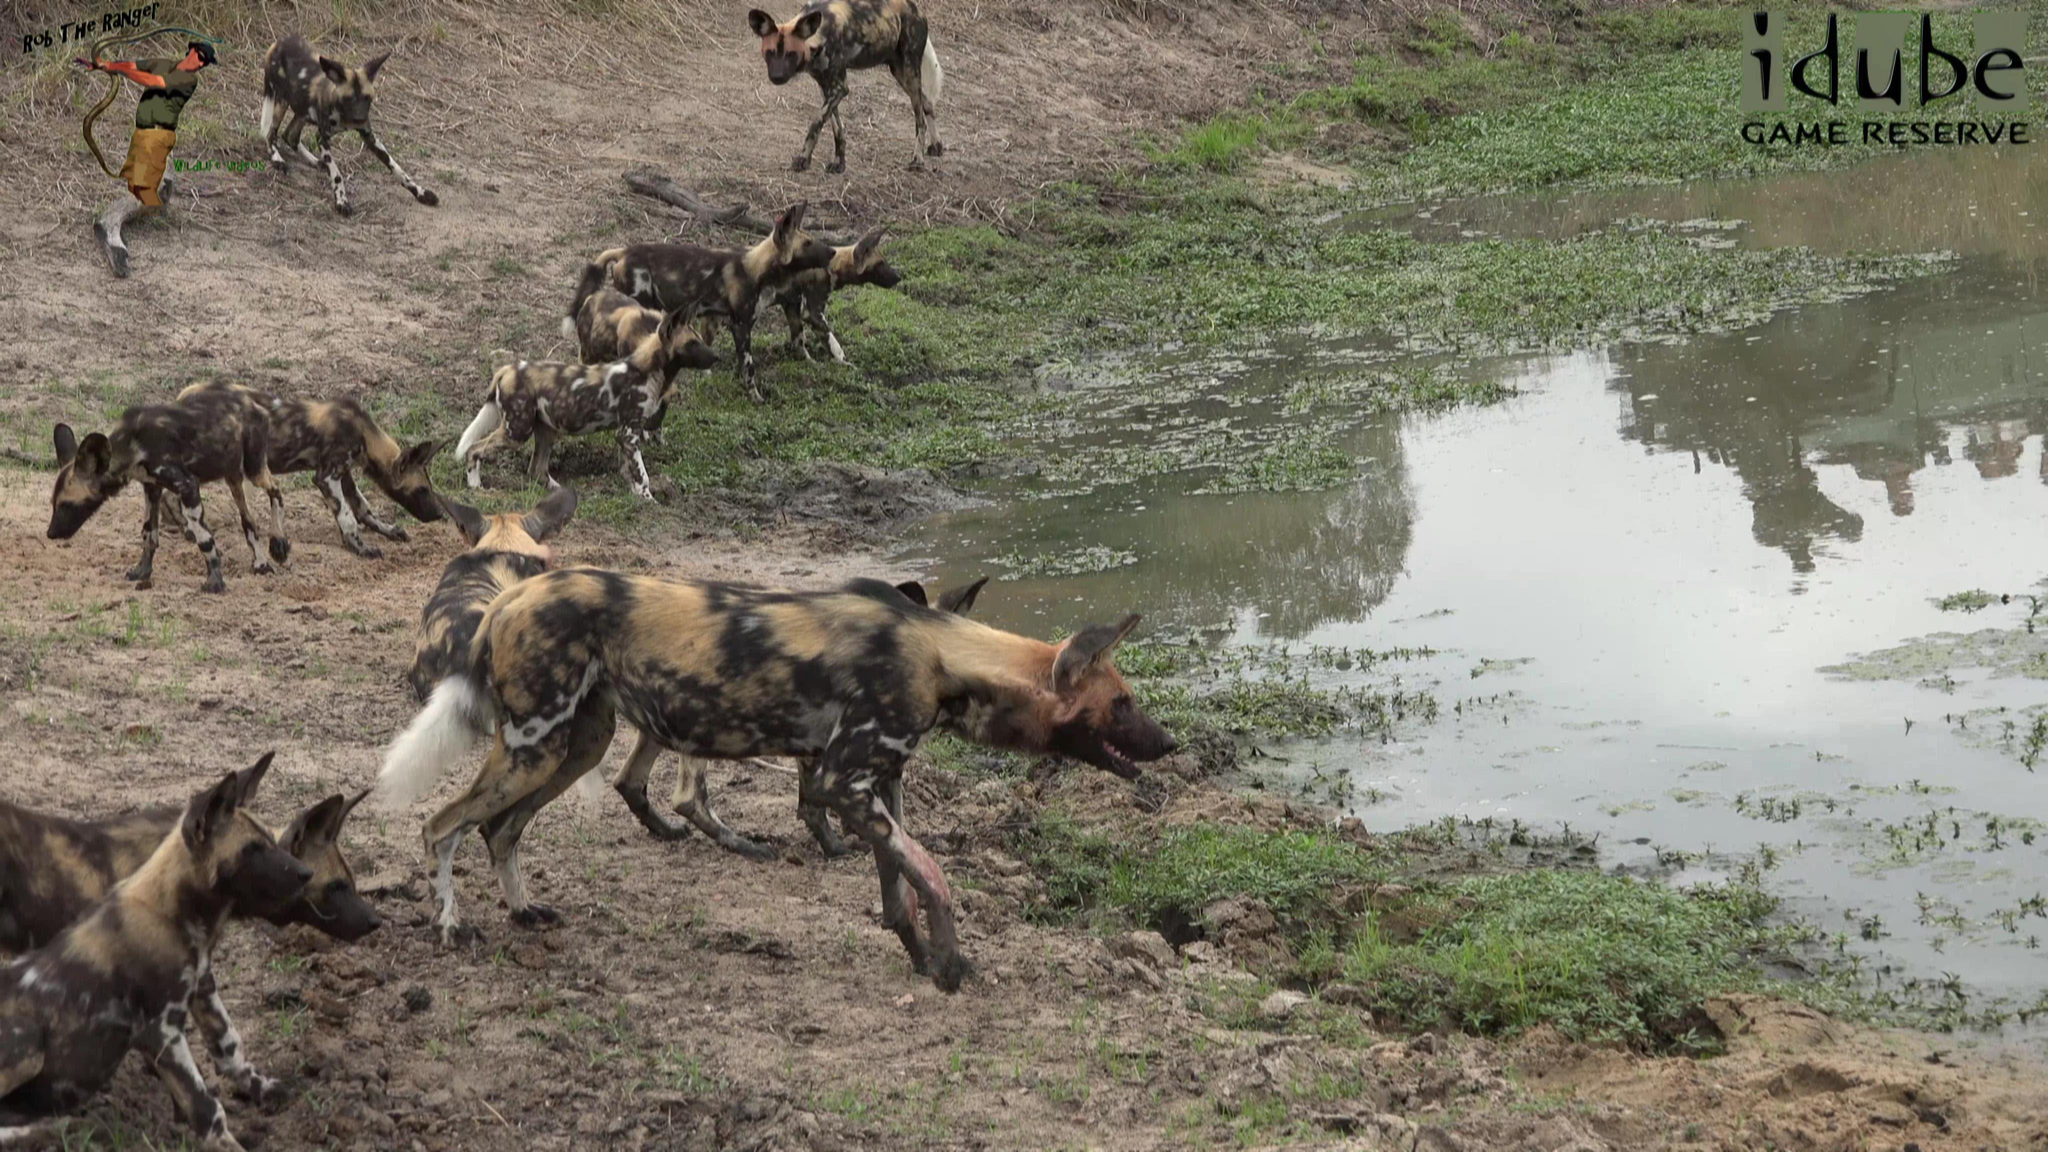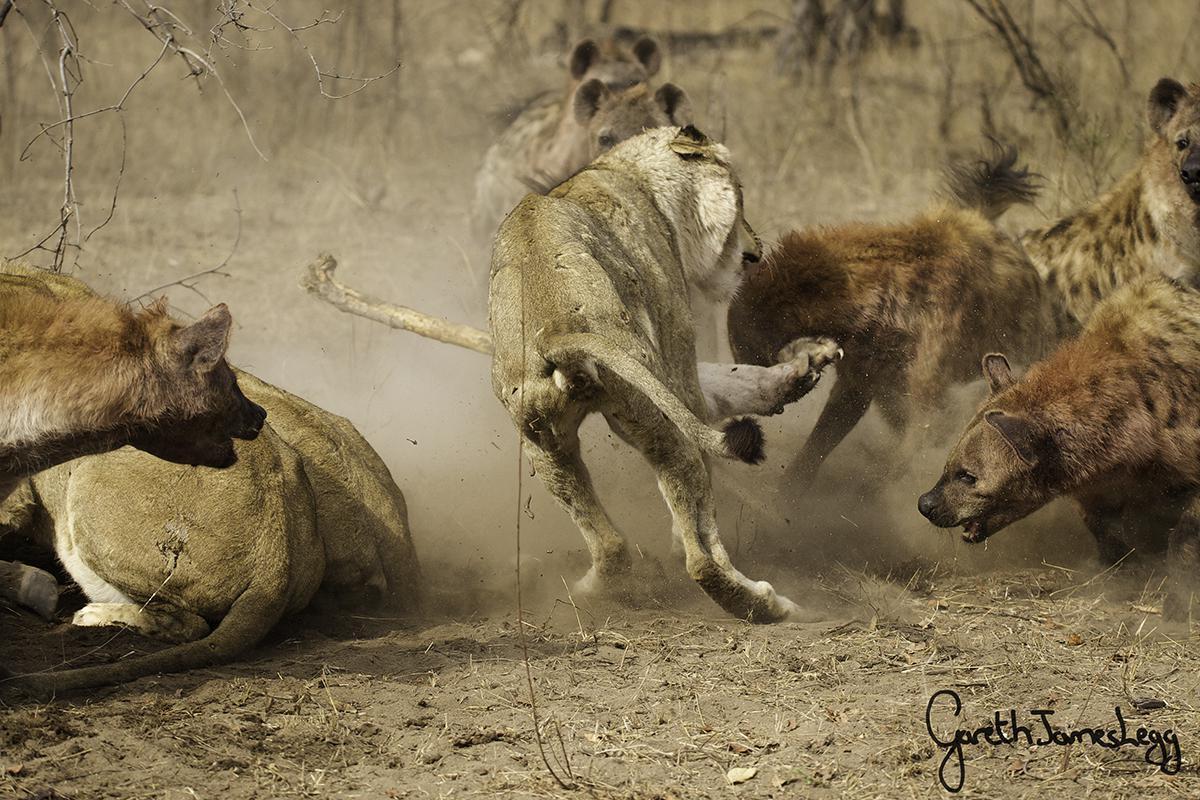The first image is the image on the left, the second image is the image on the right. For the images displayed, is the sentence "An image shows at least six hyenas, with multicolored fur featuring blotches of color instead of spots, standing around a watering hole." factually correct? Answer yes or no. Yes. The first image is the image on the left, the second image is the image on the right. Analyze the images presented: Is the assertion "There are at least six wild dogs are standing on the shore line." valid? Answer yes or no. Yes. 